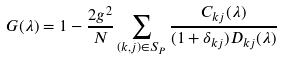Convert formula to latex. <formula><loc_0><loc_0><loc_500><loc_500>G ( \lambda ) = 1 - \frac { 2 g ^ { 2 } } { N } \sum _ { ( k , j ) \in S _ { P } } \frac { C _ { k j } ( \lambda ) } { ( 1 + \delta _ { k j } ) D _ { k j } ( \lambda ) }</formula> 